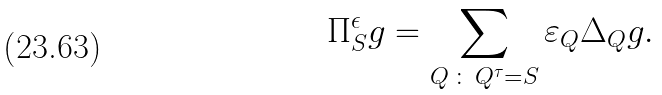Convert formula to latex. <formula><loc_0><loc_0><loc_500><loc_500>\Pi ^ { \epsilon } _ { S } g = \sum _ { Q \, \colon \, Q ^ { \tau } = S } \varepsilon _ { Q } \Delta _ { Q } g .</formula> 